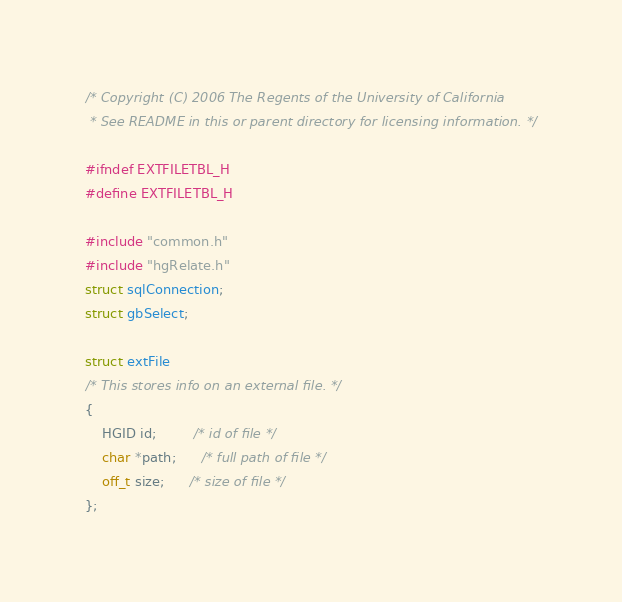Convert code to text. <code><loc_0><loc_0><loc_500><loc_500><_C_>/* Copyright (C) 2006 The Regents of the University of California 
 * See README in this or parent directory for licensing information. */

#ifndef EXTFILETBL_H
#define EXTFILETBL_H

#include "common.h"
#include "hgRelate.h"
struct sqlConnection;
struct gbSelect;

struct extFile
/* This stores info on an external file. */
{
    HGID id;         /* id of file */
    char *path;      /* full path of file */
    off_t size;      /* size of file */
};
</code> 